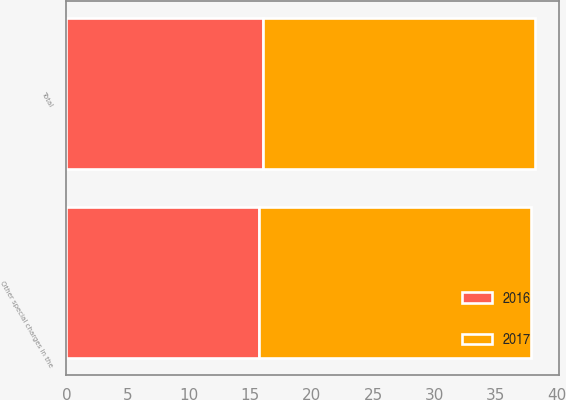Convert chart. <chart><loc_0><loc_0><loc_500><loc_500><stacked_bar_chart><ecel><fcel>Other special charges in the<fcel>Total<nl><fcel>2017<fcel>22.2<fcel>22.2<nl><fcel>2016<fcel>15.7<fcel>16<nl></chart> 